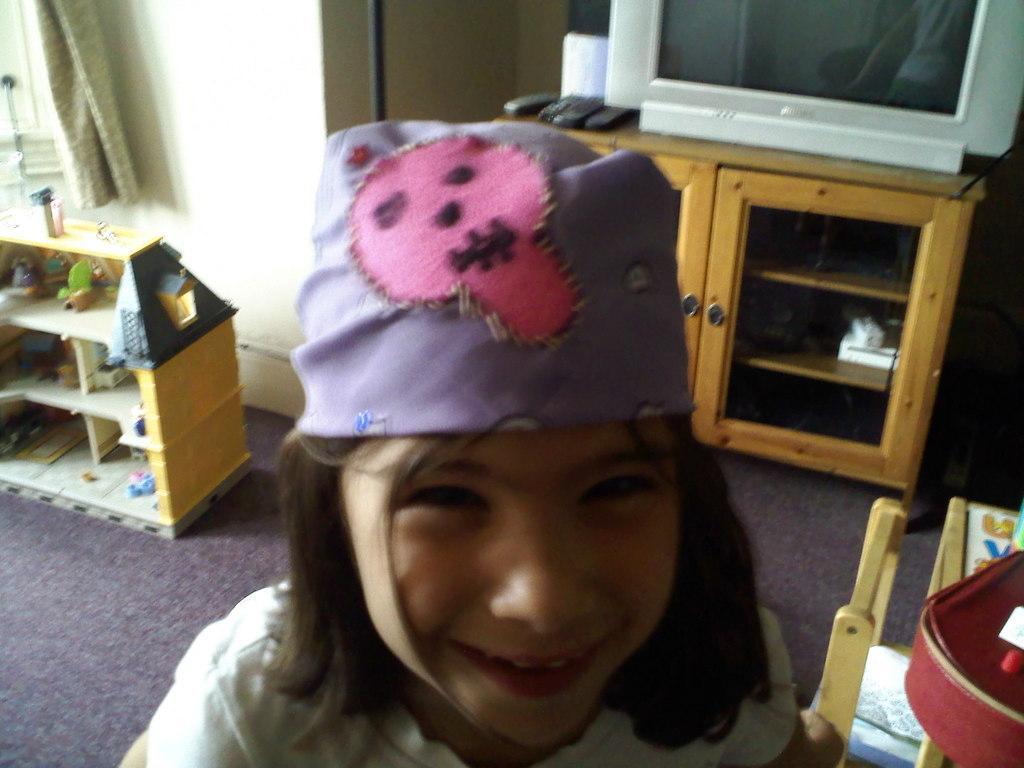How would you summarize this image in a sentence or two? At the bottom we can see a kid and there is a cap on the head. In the background there is a TV and remotes on a cupboard table, pole, curtain, wall and on the right side there is an object on a table and chair. On the left side there are objects on the racks on the floor. 